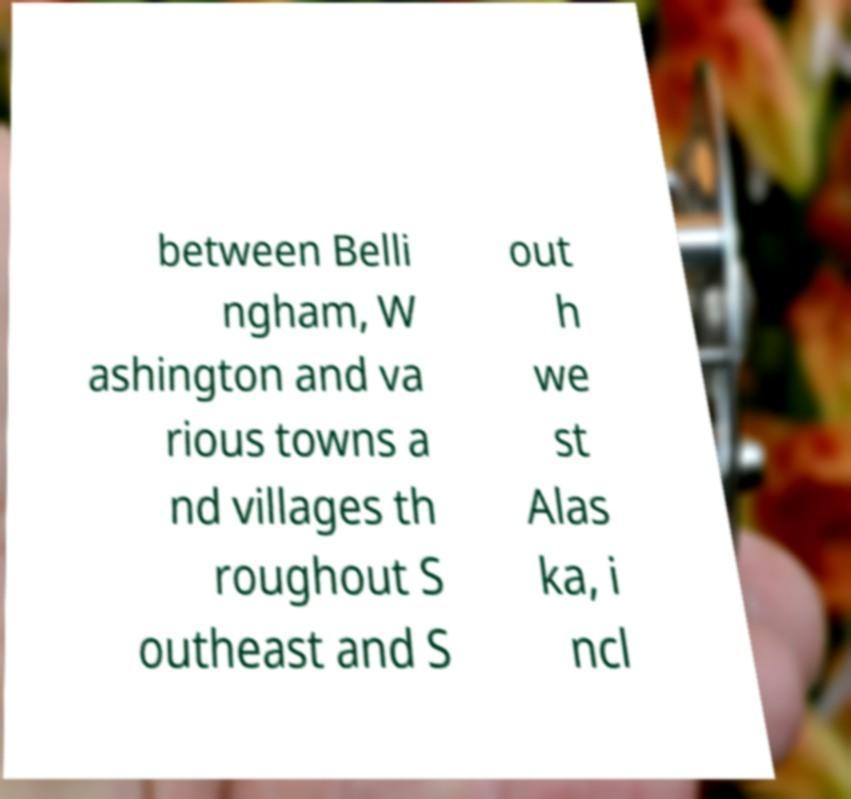Could you assist in decoding the text presented in this image and type it out clearly? between Belli ngham, W ashington and va rious towns a nd villages th roughout S outheast and S out h we st Alas ka, i ncl 